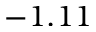Convert formula to latex. <formula><loc_0><loc_0><loc_500><loc_500>- 1 . 1 1</formula> 